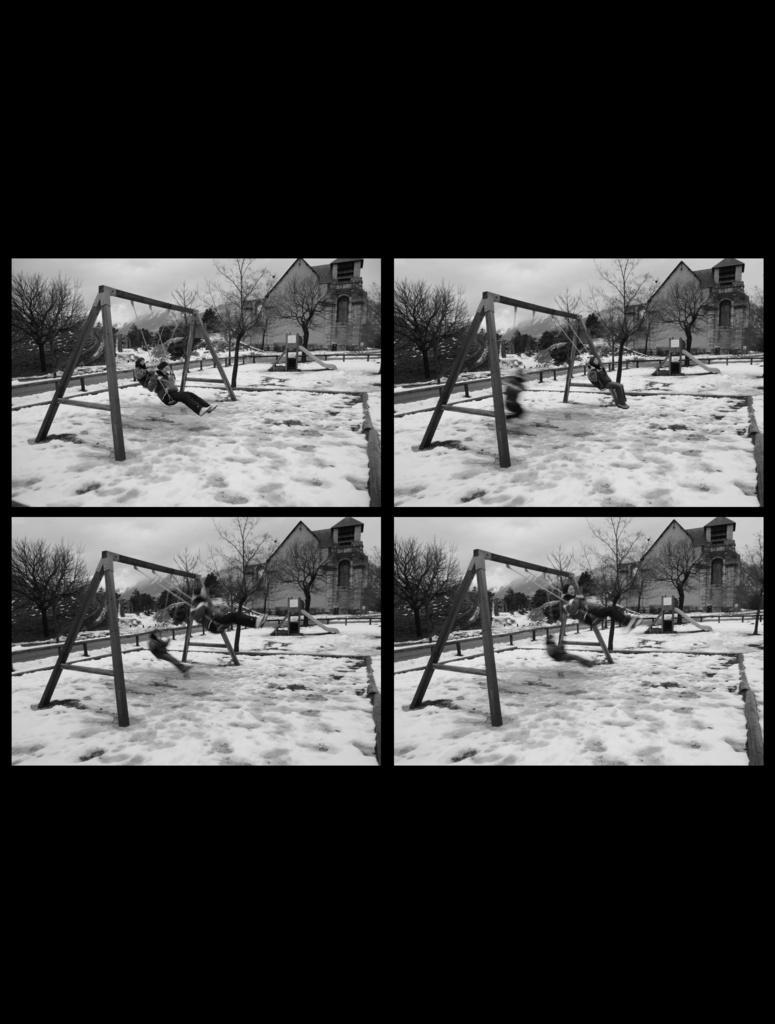In one or two sentences, can you explain what this image depicts? I can see this is a black and white picture that collaged with four images. There are two persons, trees, there is an iron stand, there is a building, barrier and in the background there is sky. And there are some other objects. 